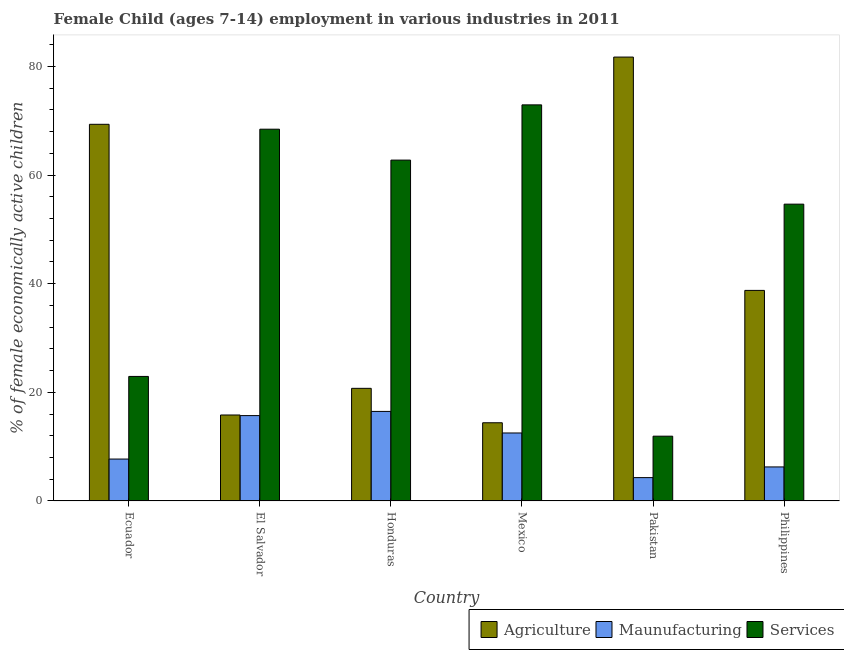Are the number of bars per tick equal to the number of legend labels?
Your response must be concise. Yes. How many bars are there on the 2nd tick from the right?
Offer a terse response. 3. What is the label of the 2nd group of bars from the left?
Your answer should be very brief. El Salvador. What is the percentage of economically active children in services in Mexico?
Provide a short and direct response. 72.93. Across all countries, what is the maximum percentage of economically active children in manufacturing?
Provide a succinct answer. 16.49. In which country was the percentage of economically active children in manufacturing maximum?
Your response must be concise. Honduras. What is the total percentage of economically active children in manufacturing in the graph?
Provide a succinct answer. 63.02. What is the difference between the percentage of economically active children in agriculture in Ecuador and that in Honduras?
Your response must be concise. 48.61. What is the difference between the percentage of economically active children in manufacturing in Honduras and the percentage of economically active children in services in El Salvador?
Your answer should be very brief. -51.96. What is the average percentage of economically active children in manufacturing per country?
Your answer should be compact. 10.5. What is the difference between the percentage of economically active children in services and percentage of economically active children in manufacturing in Pakistan?
Make the answer very short. 7.63. In how many countries, is the percentage of economically active children in services greater than 72 %?
Ensure brevity in your answer.  1. What is the ratio of the percentage of economically active children in agriculture in Ecuador to that in El Salvador?
Your answer should be compact. 4.38. Is the percentage of economically active children in services in El Salvador less than that in Honduras?
Your answer should be very brief. No. Is the difference between the percentage of economically active children in agriculture in Ecuador and El Salvador greater than the difference between the percentage of economically active children in manufacturing in Ecuador and El Salvador?
Make the answer very short. Yes. What is the difference between the highest and the second highest percentage of economically active children in agriculture?
Your response must be concise. 12.38. What is the difference between the highest and the lowest percentage of economically active children in agriculture?
Ensure brevity in your answer.  67.33. In how many countries, is the percentage of economically active children in services greater than the average percentage of economically active children in services taken over all countries?
Give a very brief answer. 4. What does the 3rd bar from the left in Philippines represents?
Your answer should be compact. Services. What does the 3rd bar from the right in El Salvador represents?
Your answer should be compact. Agriculture. Is it the case that in every country, the sum of the percentage of economically active children in agriculture and percentage of economically active children in manufacturing is greater than the percentage of economically active children in services?
Your answer should be very brief. No. Are all the bars in the graph horizontal?
Keep it short and to the point. No. How many countries are there in the graph?
Ensure brevity in your answer.  6. Does the graph contain grids?
Provide a short and direct response. No. What is the title of the graph?
Offer a very short reply. Female Child (ages 7-14) employment in various industries in 2011. What is the label or title of the X-axis?
Offer a terse response. Country. What is the label or title of the Y-axis?
Give a very brief answer. % of female economically active children. What is the % of female economically active children in Agriculture in Ecuador?
Your response must be concise. 69.35. What is the % of female economically active children of Maunufacturing in Ecuador?
Ensure brevity in your answer.  7.72. What is the % of female economically active children of Services in Ecuador?
Make the answer very short. 22.93. What is the % of female economically active children in Agriculture in El Salvador?
Make the answer very short. 15.83. What is the % of female economically active children of Maunufacturing in El Salvador?
Provide a short and direct response. 15.72. What is the % of female economically active children in Services in El Salvador?
Offer a very short reply. 68.45. What is the % of female economically active children in Agriculture in Honduras?
Keep it short and to the point. 20.74. What is the % of female economically active children of Maunufacturing in Honduras?
Offer a very short reply. 16.49. What is the % of female economically active children of Services in Honduras?
Make the answer very short. 62.76. What is the % of female economically active children of Maunufacturing in Mexico?
Your answer should be compact. 12.52. What is the % of female economically active children of Services in Mexico?
Provide a succinct answer. 72.93. What is the % of female economically active children of Agriculture in Pakistan?
Ensure brevity in your answer.  81.73. What is the % of female economically active children of Services in Pakistan?
Your answer should be very brief. 11.93. What is the % of female economically active children of Agriculture in Philippines?
Offer a terse response. 38.77. What is the % of female economically active children of Maunufacturing in Philippines?
Provide a succinct answer. 6.27. What is the % of female economically active children in Services in Philippines?
Provide a succinct answer. 54.65. Across all countries, what is the maximum % of female economically active children in Agriculture?
Your answer should be compact. 81.73. Across all countries, what is the maximum % of female economically active children in Maunufacturing?
Provide a short and direct response. 16.49. Across all countries, what is the maximum % of female economically active children of Services?
Keep it short and to the point. 72.93. Across all countries, what is the minimum % of female economically active children of Maunufacturing?
Offer a terse response. 4.3. Across all countries, what is the minimum % of female economically active children of Services?
Provide a short and direct response. 11.93. What is the total % of female economically active children in Agriculture in the graph?
Keep it short and to the point. 240.82. What is the total % of female economically active children of Maunufacturing in the graph?
Offer a very short reply. 63.02. What is the total % of female economically active children in Services in the graph?
Make the answer very short. 293.65. What is the difference between the % of female economically active children in Agriculture in Ecuador and that in El Salvador?
Your response must be concise. 53.52. What is the difference between the % of female economically active children in Maunufacturing in Ecuador and that in El Salvador?
Your answer should be compact. -8. What is the difference between the % of female economically active children in Services in Ecuador and that in El Salvador?
Make the answer very short. -45.52. What is the difference between the % of female economically active children in Agriculture in Ecuador and that in Honduras?
Ensure brevity in your answer.  48.61. What is the difference between the % of female economically active children in Maunufacturing in Ecuador and that in Honduras?
Ensure brevity in your answer.  -8.77. What is the difference between the % of female economically active children of Services in Ecuador and that in Honduras?
Provide a succinct answer. -39.83. What is the difference between the % of female economically active children in Agriculture in Ecuador and that in Mexico?
Offer a very short reply. 54.95. What is the difference between the % of female economically active children of Maunufacturing in Ecuador and that in Mexico?
Offer a very short reply. -4.8. What is the difference between the % of female economically active children of Agriculture in Ecuador and that in Pakistan?
Your response must be concise. -12.38. What is the difference between the % of female economically active children of Maunufacturing in Ecuador and that in Pakistan?
Provide a succinct answer. 3.42. What is the difference between the % of female economically active children in Agriculture in Ecuador and that in Philippines?
Provide a succinct answer. 30.58. What is the difference between the % of female economically active children in Maunufacturing in Ecuador and that in Philippines?
Keep it short and to the point. 1.45. What is the difference between the % of female economically active children in Services in Ecuador and that in Philippines?
Offer a terse response. -31.72. What is the difference between the % of female economically active children in Agriculture in El Salvador and that in Honduras?
Your response must be concise. -4.91. What is the difference between the % of female economically active children in Maunufacturing in El Salvador and that in Honduras?
Ensure brevity in your answer.  -0.77. What is the difference between the % of female economically active children of Services in El Salvador and that in Honduras?
Your answer should be very brief. 5.69. What is the difference between the % of female economically active children in Agriculture in El Salvador and that in Mexico?
Provide a succinct answer. 1.43. What is the difference between the % of female economically active children of Services in El Salvador and that in Mexico?
Make the answer very short. -4.48. What is the difference between the % of female economically active children in Agriculture in El Salvador and that in Pakistan?
Provide a short and direct response. -65.9. What is the difference between the % of female economically active children in Maunufacturing in El Salvador and that in Pakistan?
Offer a terse response. 11.42. What is the difference between the % of female economically active children in Services in El Salvador and that in Pakistan?
Your response must be concise. 56.52. What is the difference between the % of female economically active children of Agriculture in El Salvador and that in Philippines?
Provide a short and direct response. -22.94. What is the difference between the % of female economically active children in Maunufacturing in El Salvador and that in Philippines?
Your response must be concise. 9.45. What is the difference between the % of female economically active children of Agriculture in Honduras and that in Mexico?
Your answer should be compact. 6.34. What is the difference between the % of female economically active children of Maunufacturing in Honduras and that in Mexico?
Give a very brief answer. 3.97. What is the difference between the % of female economically active children of Services in Honduras and that in Mexico?
Your answer should be very brief. -10.17. What is the difference between the % of female economically active children in Agriculture in Honduras and that in Pakistan?
Your answer should be compact. -60.99. What is the difference between the % of female economically active children of Maunufacturing in Honduras and that in Pakistan?
Your answer should be very brief. 12.19. What is the difference between the % of female economically active children of Services in Honduras and that in Pakistan?
Provide a succinct answer. 50.83. What is the difference between the % of female economically active children of Agriculture in Honduras and that in Philippines?
Provide a succinct answer. -18.03. What is the difference between the % of female economically active children in Maunufacturing in Honduras and that in Philippines?
Your answer should be compact. 10.22. What is the difference between the % of female economically active children of Services in Honduras and that in Philippines?
Your answer should be compact. 8.11. What is the difference between the % of female economically active children in Agriculture in Mexico and that in Pakistan?
Make the answer very short. -67.33. What is the difference between the % of female economically active children of Maunufacturing in Mexico and that in Pakistan?
Offer a terse response. 8.22. What is the difference between the % of female economically active children in Agriculture in Mexico and that in Philippines?
Your answer should be very brief. -24.37. What is the difference between the % of female economically active children in Maunufacturing in Mexico and that in Philippines?
Provide a short and direct response. 6.25. What is the difference between the % of female economically active children of Services in Mexico and that in Philippines?
Offer a very short reply. 18.28. What is the difference between the % of female economically active children in Agriculture in Pakistan and that in Philippines?
Offer a terse response. 42.96. What is the difference between the % of female economically active children in Maunufacturing in Pakistan and that in Philippines?
Your answer should be compact. -1.97. What is the difference between the % of female economically active children in Services in Pakistan and that in Philippines?
Your answer should be compact. -42.72. What is the difference between the % of female economically active children in Agriculture in Ecuador and the % of female economically active children in Maunufacturing in El Salvador?
Provide a succinct answer. 53.63. What is the difference between the % of female economically active children in Agriculture in Ecuador and the % of female economically active children in Services in El Salvador?
Provide a short and direct response. 0.9. What is the difference between the % of female economically active children in Maunufacturing in Ecuador and the % of female economically active children in Services in El Salvador?
Ensure brevity in your answer.  -60.73. What is the difference between the % of female economically active children of Agriculture in Ecuador and the % of female economically active children of Maunufacturing in Honduras?
Your response must be concise. 52.86. What is the difference between the % of female economically active children in Agriculture in Ecuador and the % of female economically active children in Services in Honduras?
Give a very brief answer. 6.59. What is the difference between the % of female economically active children in Maunufacturing in Ecuador and the % of female economically active children in Services in Honduras?
Keep it short and to the point. -55.04. What is the difference between the % of female economically active children of Agriculture in Ecuador and the % of female economically active children of Maunufacturing in Mexico?
Provide a succinct answer. 56.83. What is the difference between the % of female economically active children of Agriculture in Ecuador and the % of female economically active children of Services in Mexico?
Your answer should be very brief. -3.58. What is the difference between the % of female economically active children of Maunufacturing in Ecuador and the % of female economically active children of Services in Mexico?
Offer a terse response. -65.21. What is the difference between the % of female economically active children of Agriculture in Ecuador and the % of female economically active children of Maunufacturing in Pakistan?
Make the answer very short. 65.05. What is the difference between the % of female economically active children in Agriculture in Ecuador and the % of female economically active children in Services in Pakistan?
Provide a short and direct response. 57.42. What is the difference between the % of female economically active children in Maunufacturing in Ecuador and the % of female economically active children in Services in Pakistan?
Your answer should be compact. -4.21. What is the difference between the % of female economically active children in Agriculture in Ecuador and the % of female economically active children in Maunufacturing in Philippines?
Ensure brevity in your answer.  63.08. What is the difference between the % of female economically active children of Agriculture in Ecuador and the % of female economically active children of Services in Philippines?
Make the answer very short. 14.7. What is the difference between the % of female economically active children in Maunufacturing in Ecuador and the % of female economically active children in Services in Philippines?
Provide a short and direct response. -46.93. What is the difference between the % of female economically active children in Agriculture in El Salvador and the % of female economically active children in Maunufacturing in Honduras?
Provide a succinct answer. -0.66. What is the difference between the % of female economically active children of Agriculture in El Salvador and the % of female economically active children of Services in Honduras?
Make the answer very short. -46.93. What is the difference between the % of female economically active children in Maunufacturing in El Salvador and the % of female economically active children in Services in Honduras?
Give a very brief answer. -47.04. What is the difference between the % of female economically active children in Agriculture in El Salvador and the % of female economically active children in Maunufacturing in Mexico?
Provide a succinct answer. 3.31. What is the difference between the % of female economically active children in Agriculture in El Salvador and the % of female economically active children in Services in Mexico?
Offer a very short reply. -57.1. What is the difference between the % of female economically active children in Maunufacturing in El Salvador and the % of female economically active children in Services in Mexico?
Your response must be concise. -57.21. What is the difference between the % of female economically active children in Agriculture in El Salvador and the % of female economically active children in Maunufacturing in Pakistan?
Your answer should be compact. 11.53. What is the difference between the % of female economically active children of Agriculture in El Salvador and the % of female economically active children of Services in Pakistan?
Your answer should be compact. 3.9. What is the difference between the % of female economically active children of Maunufacturing in El Salvador and the % of female economically active children of Services in Pakistan?
Provide a succinct answer. 3.79. What is the difference between the % of female economically active children in Agriculture in El Salvador and the % of female economically active children in Maunufacturing in Philippines?
Make the answer very short. 9.56. What is the difference between the % of female economically active children of Agriculture in El Salvador and the % of female economically active children of Services in Philippines?
Your response must be concise. -38.82. What is the difference between the % of female economically active children of Maunufacturing in El Salvador and the % of female economically active children of Services in Philippines?
Give a very brief answer. -38.93. What is the difference between the % of female economically active children in Agriculture in Honduras and the % of female economically active children in Maunufacturing in Mexico?
Provide a succinct answer. 8.22. What is the difference between the % of female economically active children of Agriculture in Honduras and the % of female economically active children of Services in Mexico?
Make the answer very short. -52.19. What is the difference between the % of female economically active children in Maunufacturing in Honduras and the % of female economically active children in Services in Mexico?
Keep it short and to the point. -56.44. What is the difference between the % of female economically active children of Agriculture in Honduras and the % of female economically active children of Maunufacturing in Pakistan?
Make the answer very short. 16.44. What is the difference between the % of female economically active children in Agriculture in Honduras and the % of female economically active children in Services in Pakistan?
Provide a short and direct response. 8.81. What is the difference between the % of female economically active children in Maunufacturing in Honduras and the % of female economically active children in Services in Pakistan?
Provide a succinct answer. 4.56. What is the difference between the % of female economically active children in Agriculture in Honduras and the % of female economically active children in Maunufacturing in Philippines?
Keep it short and to the point. 14.47. What is the difference between the % of female economically active children in Agriculture in Honduras and the % of female economically active children in Services in Philippines?
Offer a very short reply. -33.91. What is the difference between the % of female economically active children of Maunufacturing in Honduras and the % of female economically active children of Services in Philippines?
Provide a short and direct response. -38.16. What is the difference between the % of female economically active children in Agriculture in Mexico and the % of female economically active children in Services in Pakistan?
Provide a succinct answer. 2.47. What is the difference between the % of female economically active children of Maunufacturing in Mexico and the % of female economically active children of Services in Pakistan?
Make the answer very short. 0.59. What is the difference between the % of female economically active children in Agriculture in Mexico and the % of female economically active children in Maunufacturing in Philippines?
Your answer should be very brief. 8.13. What is the difference between the % of female economically active children in Agriculture in Mexico and the % of female economically active children in Services in Philippines?
Keep it short and to the point. -40.25. What is the difference between the % of female economically active children of Maunufacturing in Mexico and the % of female economically active children of Services in Philippines?
Offer a very short reply. -42.13. What is the difference between the % of female economically active children in Agriculture in Pakistan and the % of female economically active children in Maunufacturing in Philippines?
Make the answer very short. 75.46. What is the difference between the % of female economically active children in Agriculture in Pakistan and the % of female economically active children in Services in Philippines?
Provide a short and direct response. 27.08. What is the difference between the % of female economically active children of Maunufacturing in Pakistan and the % of female economically active children of Services in Philippines?
Provide a succinct answer. -50.35. What is the average % of female economically active children of Agriculture per country?
Provide a succinct answer. 40.14. What is the average % of female economically active children of Maunufacturing per country?
Offer a terse response. 10.5. What is the average % of female economically active children of Services per country?
Your response must be concise. 48.94. What is the difference between the % of female economically active children of Agriculture and % of female economically active children of Maunufacturing in Ecuador?
Offer a terse response. 61.63. What is the difference between the % of female economically active children of Agriculture and % of female economically active children of Services in Ecuador?
Your response must be concise. 46.42. What is the difference between the % of female economically active children in Maunufacturing and % of female economically active children in Services in Ecuador?
Offer a terse response. -15.21. What is the difference between the % of female economically active children of Agriculture and % of female economically active children of Maunufacturing in El Salvador?
Give a very brief answer. 0.11. What is the difference between the % of female economically active children of Agriculture and % of female economically active children of Services in El Salvador?
Your answer should be compact. -52.62. What is the difference between the % of female economically active children in Maunufacturing and % of female economically active children in Services in El Salvador?
Give a very brief answer. -52.73. What is the difference between the % of female economically active children of Agriculture and % of female economically active children of Maunufacturing in Honduras?
Your response must be concise. 4.25. What is the difference between the % of female economically active children in Agriculture and % of female economically active children in Services in Honduras?
Ensure brevity in your answer.  -42.02. What is the difference between the % of female economically active children in Maunufacturing and % of female economically active children in Services in Honduras?
Your answer should be compact. -46.27. What is the difference between the % of female economically active children in Agriculture and % of female economically active children in Maunufacturing in Mexico?
Your answer should be very brief. 1.88. What is the difference between the % of female economically active children in Agriculture and % of female economically active children in Services in Mexico?
Offer a terse response. -58.53. What is the difference between the % of female economically active children of Maunufacturing and % of female economically active children of Services in Mexico?
Offer a very short reply. -60.41. What is the difference between the % of female economically active children in Agriculture and % of female economically active children in Maunufacturing in Pakistan?
Give a very brief answer. 77.43. What is the difference between the % of female economically active children of Agriculture and % of female economically active children of Services in Pakistan?
Your answer should be very brief. 69.8. What is the difference between the % of female economically active children of Maunufacturing and % of female economically active children of Services in Pakistan?
Provide a short and direct response. -7.63. What is the difference between the % of female economically active children of Agriculture and % of female economically active children of Maunufacturing in Philippines?
Offer a terse response. 32.5. What is the difference between the % of female economically active children of Agriculture and % of female economically active children of Services in Philippines?
Offer a very short reply. -15.88. What is the difference between the % of female economically active children in Maunufacturing and % of female economically active children in Services in Philippines?
Offer a very short reply. -48.38. What is the ratio of the % of female economically active children in Agriculture in Ecuador to that in El Salvador?
Offer a terse response. 4.38. What is the ratio of the % of female economically active children in Maunufacturing in Ecuador to that in El Salvador?
Offer a very short reply. 0.49. What is the ratio of the % of female economically active children of Services in Ecuador to that in El Salvador?
Your answer should be compact. 0.34. What is the ratio of the % of female economically active children in Agriculture in Ecuador to that in Honduras?
Your answer should be very brief. 3.34. What is the ratio of the % of female economically active children of Maunufacturing in Ecuador to that in Honduras?
Make the answer very short. 0.47. What is the ratio of the % of female economically active children in Services in Ecuador to that in Honduras?
Offer a very short reply. 0.37. What is the ratio of the % of female economically active children of Agriculture in Ecuador to that in Mexico?
Ensure brevity in your answer.  4.82. What is the ratio of the % of female economically active children in Maunufacturing in Ecuador to that in Mexico?
Give a very brief answer. 0.62. What is the ratio of the % of female economically active children of Services in Ecuador to that in Mexico?
Provide a short and direct response. 0.31. What is the ratio of the % of female economically active children in Agriculture in Ecuador to that in Pakistan?
Provide a succinct answer. 0.85. What is the ratio of the % of female economically active children of Maunufacturing in Ecuador to that in Pakistan?
Provide a succinct answer. 1.8. What is the ratio of the % of female economically active children of Services in Ecuador to that in Pakistan?
Offer a terse response. 1.92. What is the ratio of the % of female economically active children in Agriculture in Ecuador to that in Philippines?
Provide a succinct answer. 1.79. What is the ratio of the % of female economically active children in Maunufacturing in Ecuador to that in Philippines?
Your response must be concise. 1.23. What is the ratio of the % of female economically active children of Services in Ecuador to that in Philippines?
Make the answer very short. 0.42. What is the ratio of the % of female economically active children in Agriculture in El Salvador to that in Honduras?
Provide a short and direct response. 0.76. What is the ratio of the % of female economically active children in Maunufacturing in El Salvador to that in Honduras?
Make the answer very short. 0.95. What is the ratio of the % of female economically active children in Services in El Salvador to that in Honduras?
Give a very brief answer. 1.09. What is the ratio of the % of female economically active children in Agriculture in El Salvador to that in Mexico?
Keep it short and to the point. 1.1. What is the ratio of the % of female economically active children in Maunufacturing in El Salvador to that in Mexico?
Give a very brief answer. 1.26. What is the ratio of the % of female economically active children in Services in El Salvador to that in Mexico?
Offer a very short reply. 0.94. What is the ratio of the % of female economically active children of Agriculture in El Salvador to that in Pakistan?
Your answer should be compact. 0.19. What is the ratio of the % of female economically active children of Maunufacturing in El Salvador to that in Pakistan?
Keep it short and to the point. 3.66. What is the ratio of the % of female economically active children in Services in El Salvador to that in Pakistan?
Offer a terse response. 5.74. What is the ratio of the % of female economically active children of Agriculture in El Salvador to that in Philippines?
Your answer should be compact. 0.41. What is the ratio of the % of female economically active children of Maunufacturing in El Salvador to that in Philippines?
Your answer should be compact. 2.51. What is the ratio of the % of female economically active children in Services in El Salvador to that in Philippines?
Offer a terse response. 1.25. What is the ratio of the % of female economically active children of Agriculture in Honduras to that in Mexico?
Provide a short and direct response. 1.44. What is the ratio of the % of female economically active children in Maunufacturing in Honduras to that in Mexico?
Ensure brevity in your answer.  1.32. What is the ratio of the % of female economically active children of Services in Honduras to that in Mexico?
Offer a very short reply. 0.86. What is the ratio of the % of female economically active children of Agriculture in Honduras to that in Pakistan?
Ensure brevity in your answer.  0.25. What is the ratio of the % of female economically active children of Maunufacturing in Honduras to that in Pakistan?
Ensure brevity in your answer.  3.83. What is the ratio of the % of female economically active children of Services in Honduras to that in Pakistan?
Offer a terse response. 5.26. What is the ratio of the % of female economically active children in Agriculture in Honduras to that in Philippines?
Provide a short and direct response. 0.53. What is the ratio of the % of female economically active children in Maunufacturing in Honduras to that in Philippines?
Give a very brief answer. 2.63. What is the ratio of the % of female economically active children of Services in Honduras to that in Philippines?
Offer a very short reply. 1.15. What is the ratio of the % of female economically active children of Agriculture in Mexico to that in Pakistan?
Offer a very short reply. 0.18. What is the ratio of the % of female economically active children in Maunufacturing in Mexico to that in Pakistan?
Your answer should be compact. 2.91. What is the ratio of the % of female economically active children of Services in Mexico to that in Pakistan?
Offer a terse response. 6.11. What is the ratio of the % of female economically active children in Agriculture in Mexico to that in Philippines?
Your answer should be compact. 0.37. What is the ratio of the % of female economically active children of Maunufacturing in Mexico to that in Philippines?
Keep it short and to the point. 2. What is the ratio of the % of female economically active children of Services in Mexico to that in Philippines?
Keep it short and to the point. 1.33. What is the ratio of the % of female economically active children of Agriculture in Pakistan to that in Philippines?
Your response must be concise. 2.11. What is the ratio of the % of female economically active children in Maunufacturing in Pakistan to that in Philippines?
Your answer should be very brief. 0.69. What is the ratio of the % of female economically active children of Services in Pakistan to that in Philippines?
Your answer should be compact. 0.22. What is the difference between the highest and the second highest % of female economically active children in Agriculture?
Ensure brevity in your answer.  12.38. What is the difference between the highest and the second highest % of female economically active children of Maunufacturing?
Provide a succinct answer. 0.77. What is the difference between the highest and the second highest % of female economically active children of Services?
Offer a very short reply. 4.48. What is the difference between the highest and the lowest % of female economically active children of Agriculture?
Make the answer very short. 67.33. What is the difference between the highest and the lowest % of female economically active children in Maunufacturing?
Keep it short and to the point. 12.19. 